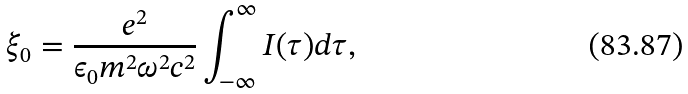<formula> <loc_0><loc_0><loc_500><loc_500>\xi _ { 0 } = \frac { e ^ { 2 } } { \epsilon _ { 0 } m ^ { 2 } \omega ^ { 2 } c ^ { 2 } } \int _ { - \infty } ^ { \infty } I ( \tau ) d \tau ,</formula> 